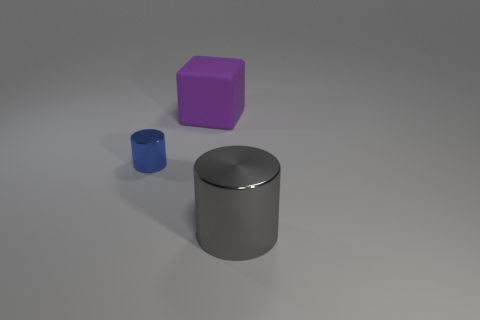Is there any other thing that is made of the same material as the big purple object?
Ensure brevity in your answer.  No. How big is the metallic object that is to the left of the thing that is to the right of the big thing that is behind the tiny cylinder?
Your answer should be compact. Small. How many purple things are either large metallic cylinders or big blocks?
Offer a terse response. 1. Is the shape of the metallic object that is in front of the small metallic cylinder the same as  the big purple matte object?
Keep it short and to the point. No. Is the number of large metal cylinders that are behind the matte thing greater than the number of blue cylinders?
Ensure brevity in your answer.  No. What number of shiny cylinders are the same size as the blue shiny thing?
Make the answer very short. 0. What number of things are small blue cylinders or metallic cylinders that are behind the gray metallic cylinder?
Provide a short and direct response. 1. There is a thing that is right of the blue metal cylinder and behind the big gray metallic cylinder; what is its color?
Offer a terse response. Purple. Do the matte block and the blue metallic object have the same size?
Offer a very short reply. No. The large thing to the left of the big metal thing is what color?
Offer a very short reply. Purple. 